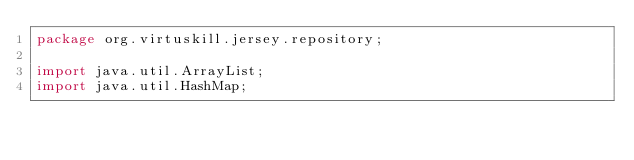<code> <loc_0><loc_0><loc_500><loc_500><_Java_>package org.virtuskill.jersey.repository;

import java.util.ArrayList;
import java.util.HashMap;</code> 